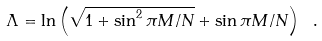<formula> <loc_0><loc_0><loc_500><loc_500>\Lambda = \ln \left ( \sqrt { 1 + \sin ^ { 2 } \pi M / N } + \sin \pi M / N \right ) \ .</formula> 